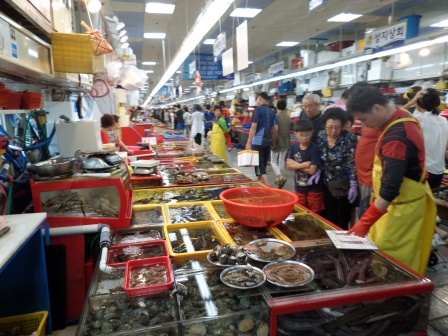What types of seafood might one find at this market? At this bustling seafood market, you are likely to find a diverse array of fresh seafood. This includes various types of fish, crabs, lobsters, shrimp, clams, mussels, oysters, and possibly even more exotic options such as sea urchins or octopus. The tanks are filled with live seafood, ensuring the freshest selection for customers. The vendors take pride in their wide offerings, providing something for every seafood lover's taste. Can you describe the interaction between a vendor and a customer? Certainly! A typical interaction at this seafood market might go something like this: A customer approaches a vendor's stall, eyeing the selection of fresh lobster in a tank. The vendor, noticing the customer's interest, welcomes them with a friendly greeting and proceeds to describe the quality and price of the lobster. They might offer to show the customer the liveliest specimens, even pulling one out of the tank for closer inspection. The vendor might share tips on the best way to prepare and cook the lobster. The customer, satisfied with the information and the quality of the product, nods in agreement and decides to make a purchase. They exchange money, and the vendor carefully packages the lobster for the customer to take home. The interaction is friendly, informative, and efficient—characteristic of the personal service one expects in such markets. 